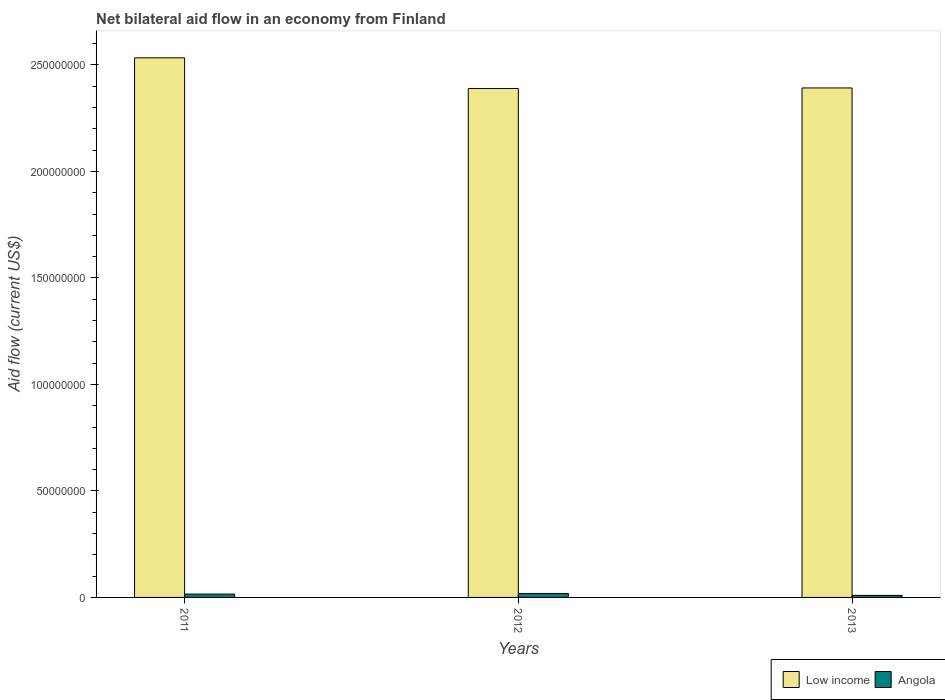How many groups of bars are there?
Make the answer very short. 3. Are the number of bars per tick equal to the number of legend labels?
Your response must be concise. Yes. Are the number of bars on each tick of the X-axis equal?
Ensure brevity in your answer.  Yes. How many bars are there on the 2nd tick from the right?
Give a very brief answer. 2. In how many cases, is the number of bars for a given year not equal to the number of legend labels?
Offer a terse response. 0. What is the net bilateral aid flow in Low income in 2011?
Give a very brief answer. 2.53e+08. Across all years, what is the maximum net bilateral aid flow in Low income?
Your answer should be very brief. 2.53e+08. Across all years, what is the minimum net bilateral aid flow in Low income?
Provide a succinct answer. 2.39e+08. In which year was the net bilateral aid flow in Low income maximum?
Make the answer very short. 2011. What is the total net bilateral aid flow in Angola in the graph?
Provide a succinct answer. 4.38e+06. What is the difference between the net bilateral aid flow in Low income in 2012 and that in 2013?
Your response must be concise. -2.50e+05. What is the difference between the net bilateral aid flow in Angola in 2011 and the net bilateral aid flow in Low income in 2012?
Ensure brevity in your answer.  -2.37e+08. What is the average net bilateral aid flow in Low income per year?
Make the answer very short. 2.44e+08. In the year 2012, what is the difference between the net bilateral aid flow in Angola and net bilateral aid flow in Low income?
Your response must be concise. -2.37e+08. What is the ratio of the net bilateral aid flow in Angola in 2011 to that in 2012?
Provide a succinct answer. 0.84. Is the net bilateral aid flow in Low income in 2011 less than that in 2013?
Your response must be concise. No. Is the difference between the net bilateral aid flow in Angola in 2011 and 2012 greater than the difference between the net bilateral aid flow in Low income in 2011 and 2012?
Provide a short and direct response. No. What is the difference between the highest and the lowest net bilateral aid flow in Angola?
Your answer should be compact. 9.10e+05. Is the sum of the net bilateral aid flow in Angola in 2011 and 2012 greater than the maximum net bilateral aid flow in Low income across all years?
Provide a succinct answer. No. What does the 2nd bar from the left in 2013 represents?
Ensure brevity in your answer.  Angola. What does the 1st bar from the right in 2011 represents?
Your response must be concise. Angola. How many bars are there?
Your response must be concise. 6. Are all the bars in the graph horizontal?
Offer a terse response. No. How many years are there in the graph?
Your answer should be compact. 3. What is the difference between two consecutive major ticks on the Y-axis?
Provide a succinct answer. 5.00e+07. Does the graph contain grids?
Your response must be concise. No. How are the legend labels stacked?
Your answer should be compact. Horizontal. What is the title of the graph?
Make the answer very short. Net bilateral aid flow in an economy from Finland. What is the label or title of the Y-axis?
Your answer should be compact. Aid flow (current US$). What is the Aid flow (current US$) of Low income in 2011?
Your answer should be very brief. 2.53e+08. What is the Aid flow (current US$) of Angola in 2011?
Keep it short and to the point. 1.57e+06. What is the Aid flow (current US$) in Low income in 2012?
Keep it short and to the point. 2.39e+08. What is the Aid flow (current US$) in Angola in 2012?
Make the answer very short. 1.86e+06. What is the Aid flow (current US$) of Low income in 2013?
Offer a very short reply. 2.39e+08. What is the Aid flow (current US$) of Angola in 2013?
Offer a very short reply. 9.50e+05. Across all years, what is the maximum Aid flow (current US$) of Low income?
Provide a succinct answer. 2.53e+08. Across all years, what is the maximum Aid flow (current US$) of Angola?
Ensure brevity in your answer.  1.86e+06. Across all years, what is the minimum Aid flow (current US$) of Low income?
Provide a succinct answer. 2.39e+08. Across all years, what is the minimum Aid flow (current US$) of Angola?
Give a very brief answer. 9.50e+05. What is the total Aid flow (current US$) of Low income in the graph?
Provide a short and direct response. 7.32e+08. What is the total Aid flow (current US$) in Angola in the graph?
Your answer should be compact. 4.38e+06. What is the difference between the Aid flow (current US$) in Low income in 2011 and that in 2012?
Your response must be concise. 1.44e+07. What is the difference between the Aid flow (current US$) in Angola in 2011 and that in 2012?
Offer a very short reply. -2.90e+05. What is the difference between the Aid flow (current US$) of Low income in 2011 and that in 2013?
Make the answer very short. 1.42e+07. What is the difference between the Aid flow (current US$) in Angola in 2011 and that in 2013?
Offer a terse response. 6.20e+05. What is the difference between the Aid flow (current US$) in Low income in 2012 and that in 2013?
Your answer should be compact. -2.50e+05. What is the difference between the Aid flow (current US$) in Angola in 2012 and that in 2013?
Offer a very short reply. 9.10e+05. What is the difference between the Aid flow (current US$) in Low income in 2011 and the Aid flow (current US$) in Angola in 2012?
Offer a terse response. 2.51e+08. What is the difference between the Aid flow (current US$) of Low income in 2011 and the Aid flow (current US$) of Angola in 2013?
Ensure brevity in your answer.  2.52e+08. What is the difference between the Aid flow (current US$) in Low income in 2012 and the Aid flow (current US$) in Angola in 2013?
Give a very brief answer. 2.38e+08. What is the average Aid flow (current US$) in Low income per year?
Your answer should be compact. 2.44e+08. What is the average Aid flow (current US$) of Angola per year?
Provide a succinct answer. 1.46e+06. In the year 2011, what is the difference between the Aid flow (current US$) of Low income and Aid flow (current US$) of Angola?
Ensure brevity in your answer.  2.52e+08. In the year 2012, what is the difference between the Aid flow (current US$) in Low income and Aid flow (current US$) in Angola?
Offer a very short reply. 2.37e+08. In the year 2013, what is the difference between the Aid flow (current US$) in Low income and Aid flow (current US$) in Angola?
Keep it short and to the point. 2.38e+08. What is the ratio of the Aid flow (current US$) of Low income in 2011 to that in 2012?
Make the answer very short. 1.06. What is the ratio of the Aid flow (current US$) in Angola in 2011 to that in 2012?
Your response must be concise. 0.84. What is the ratio of the Aid flow (current US$) in Low income in 2011 to that in 2013?
Offer a very short reply. 1.06. What is the ratio of the Aid flow (current US$) in Angola in 2011 to that in 2013?
Make the answer very short. 1.65. What is the ratio of the Aid flow (current US$) of Angola in 2012 to that in 2013?
Keep it short and to the point. 1.96. What is the difference between the highest and the second highest Aid flow (current US$) in Low income?
Keep it short and to the point. 1.42e+07. What is the difference between the highest and the lowest Aid flow (current US$) of Low income?
Provide a short and direct response. 1.44e+07. What is the difference between the highest and the lowest Aid flow (current US$) in Angola?
Ensure brevity in your answer.  9.10e+05. 